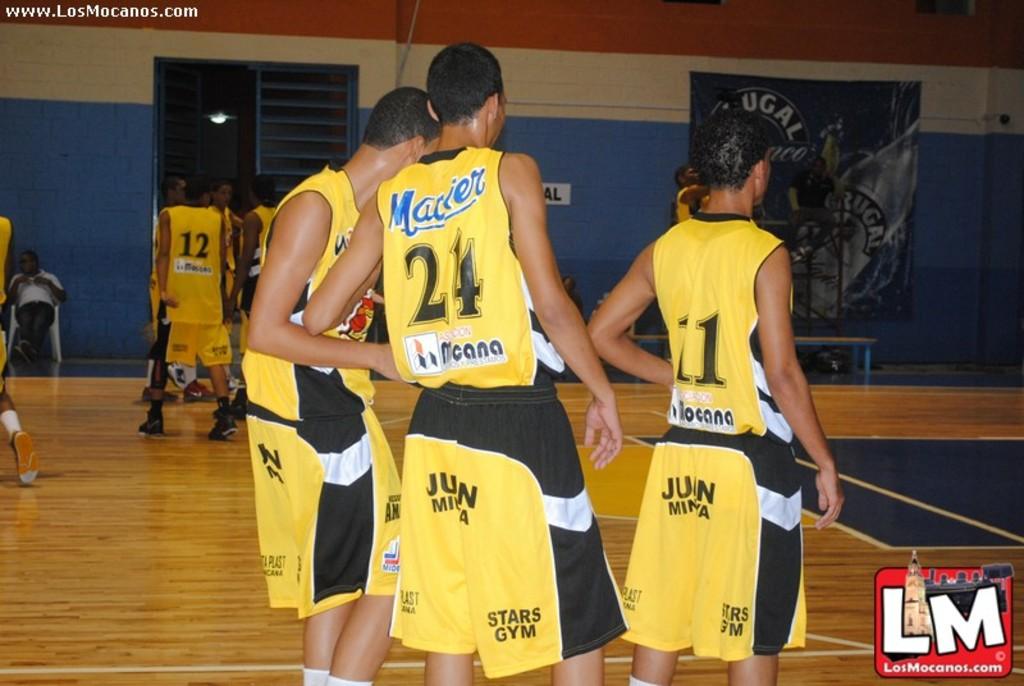What number is on the shortest player back ?
Provide a short and direct response. 11. What team is this?
Provide a succinct answer. Unanswerable. 